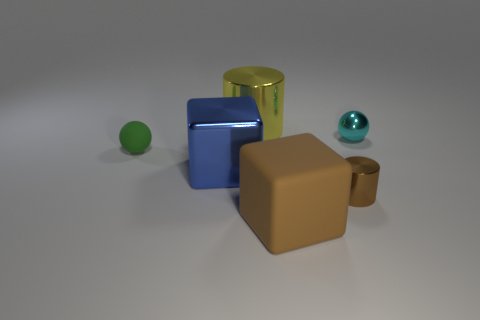Subtract all red blocks. Subtract all purple cylinders. How many blocks are left? 2 Add 1 big brown metal objects. How many objects exist? 7 Subtract all cylinders. How many objects are left? 4 Add 6 brown metallic objects. How many brown metallic objects are left? 7 Add 5 brown rubber blocks. How many brown rubber blocks exist? 6 Subtract 0 purple balls. How many objects are left? 6 Subtract all tiny brown metallic cylinders. Subtract all cyan shiny cubes. How many objects are left? 5 